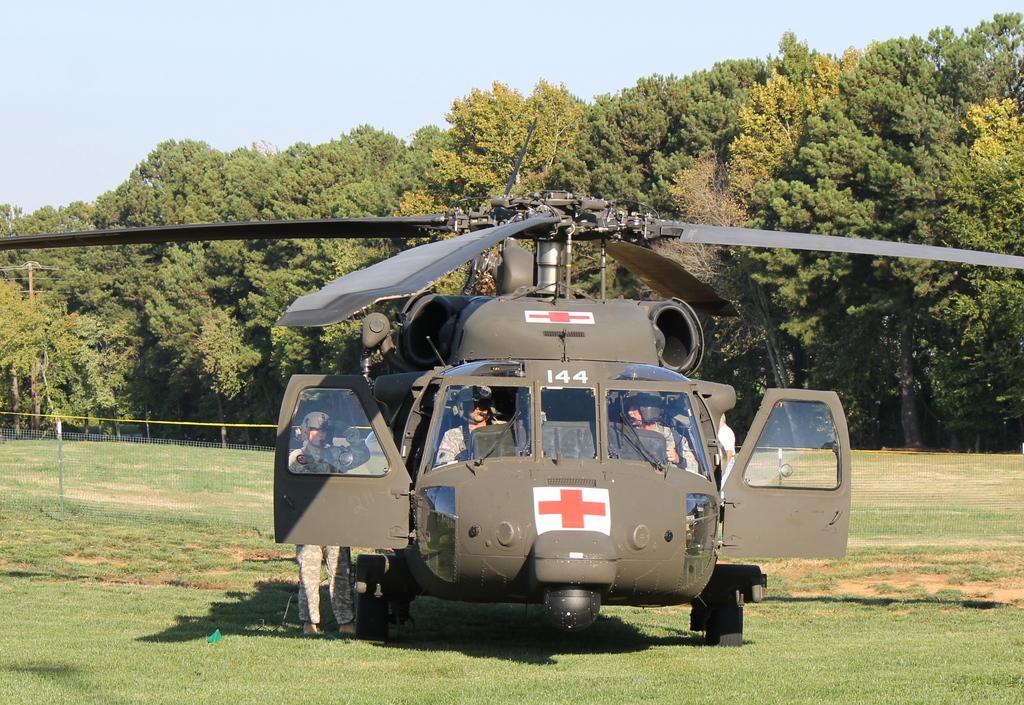Could you give a brief overview of what you see in this image? In this image we can see a helicopter, fence, persons and other objects. In the background of the image there are trees. At the top of the image there is the sky. At the bottom of the image there is the grass. 